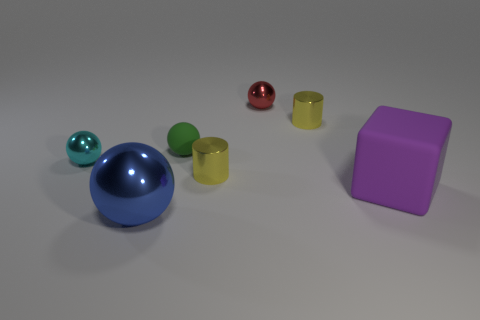How many yellow cylinders must be subtracted to get 1 yellow cylinders? 1 Subtract all blue balls. How many balls are left? 3 Add 3 small green objects. How many objects exist? 10 Subtract all red balls. How many balls are left? 3 Subtract all blocks. How many objects are left? 6 Add 5 green things. How many green things exist? 6 Subtract 1 green spheres. How many objects are left? 6 Subtract all cyan balls. Subtract all green cubes. How many balls are left? 3 Subtract all tiny yellow metallic cylinders. Subtract all blue balls. How many objects are left? 4 Add 4 small green balls. How many small green balls are left? 5 